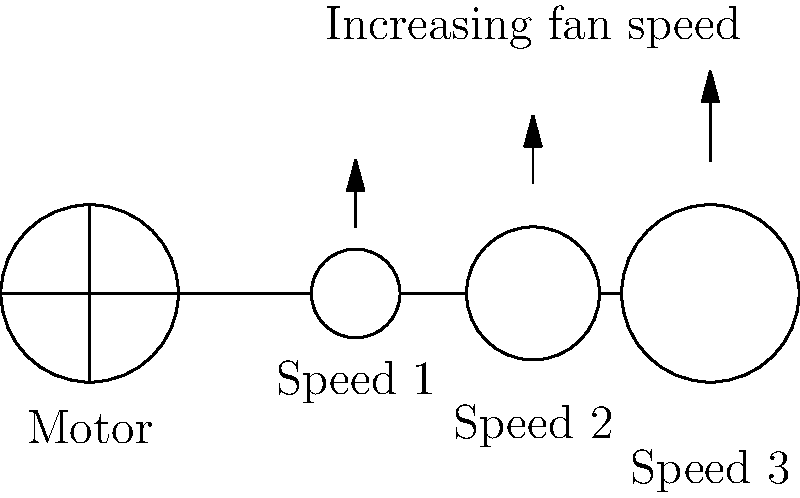In a multi-speed ceiling fan system, the motor is connected to three gears of increasing sizes. If the largest gear (Speed 3) rotates at 120 RPM when engaged, what would be the approximate rotation speed of the smallest gear (Speed 1) if it were engaged instead, assuming the motor maintains a constant output? To solve this problem, we need to understand the relationship between gear size and rotational speed:

1. In a gear system, the product of gear size and rotational speed remains constant for all gears connected to the same motor.

2. Let's denote the radius of each gear as $r_1$, $r_2$, and $r_3$ for Speed 1, 2, and 3 respectively.

3. From the diagram, we can estimate that $r_3 : r_2 : r_1 ≈ 2 : 1.5 : 1$

4. We know that Speed 3 (largest gear) rotates at 120 RPM.

5. Using the gear ratio principle:
   $r_3 \cdot 120 = r_1 \cdot x$, where $x$ is the rotational speed of the smallest gear.

6. Substituting the ratios:
   $2 \cdot 120 = 1 \cdot x$

7. Solving for $x$:
   $x = 2 \cdot 120 = 240$ RPM

Therefore, the smallest gear (Speed 1) would rotate at approximately 240 RPM when engaged.
Answer: 240 RPM 